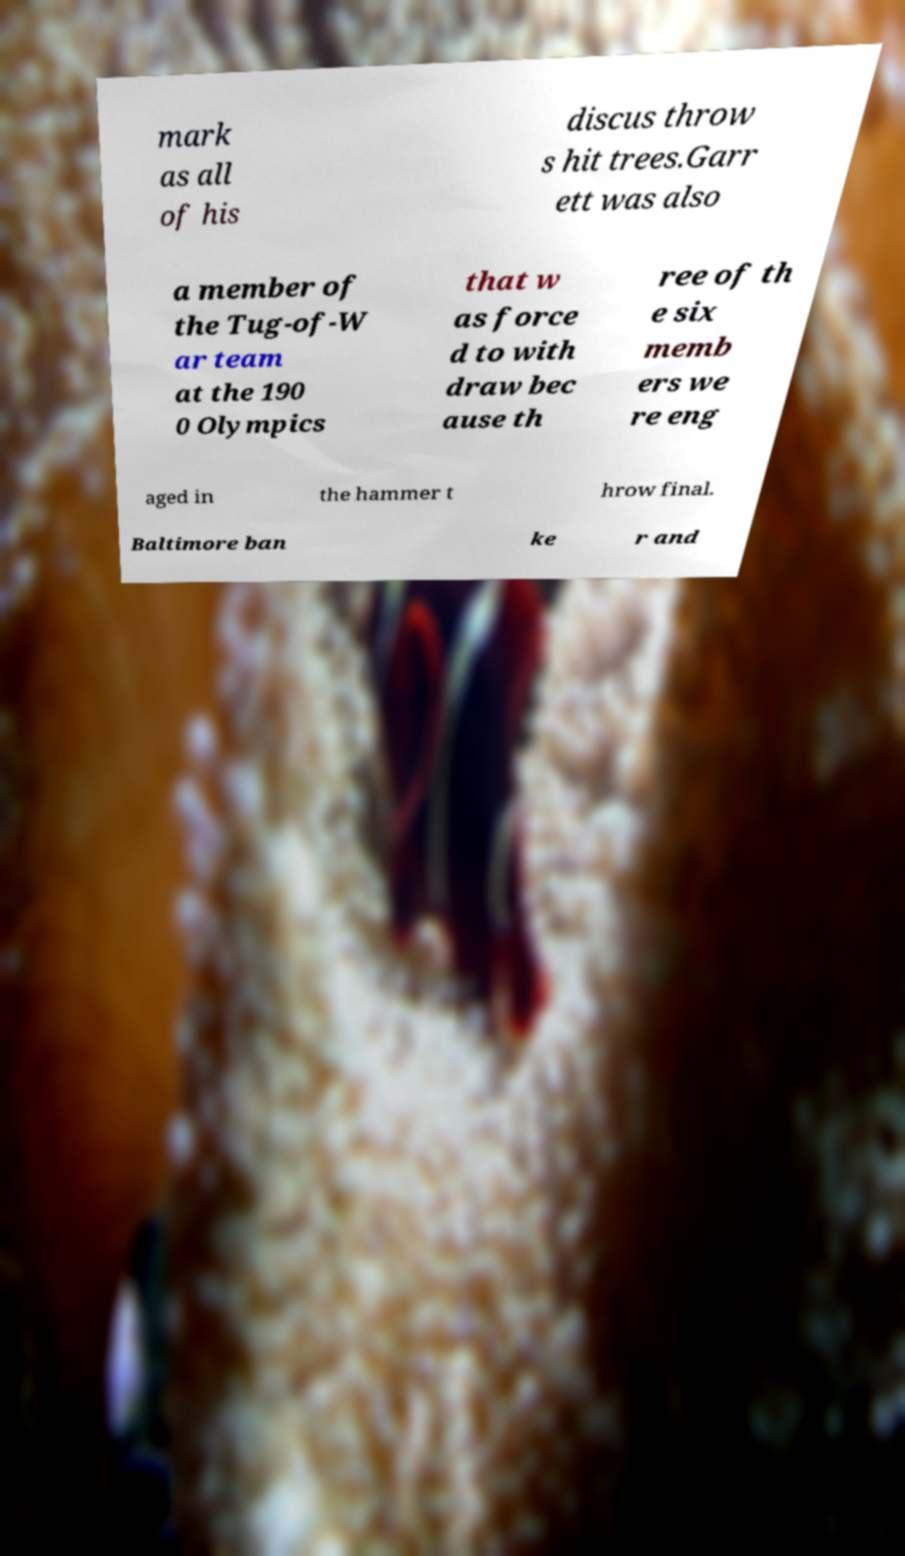Please identify and transcribe the text found in this image. mark as all of his discus throw s hit trees.Garr ett was also a member of the Tug-of-W ar team at the 190 0 Olympics that w as force d to with draw bec ause th ree of th e six memb ers we re eng aged in the hammer t hrow final. Baltimore ban ke r and 